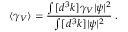<formula> <loc_0><loc_0><loc_500><loc_500>\langle \gamma _ { V } \rangle = \frac { \int [ d ^ { 3 } k ] \gamma _ { V } | \psi | ^ { 2 } } { \int [ d ^ { 3 } k ] | \psi | ^ { 2 } } \, .</formula> 